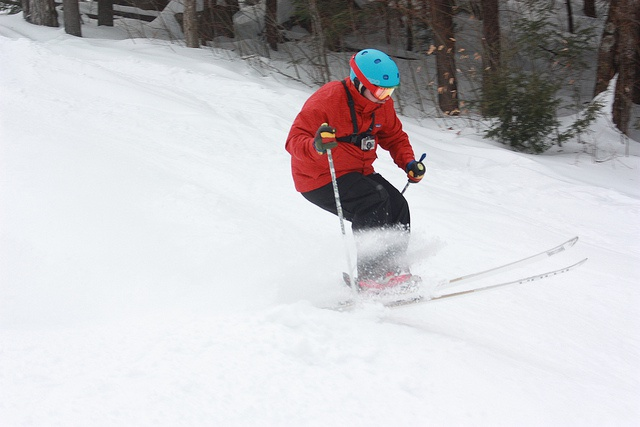Describe the objects in this image and their specific colors. I can see people in black, brown, lightgray, and darkgray tones and skis in black, lightgray, and darkgray tones in this image. 